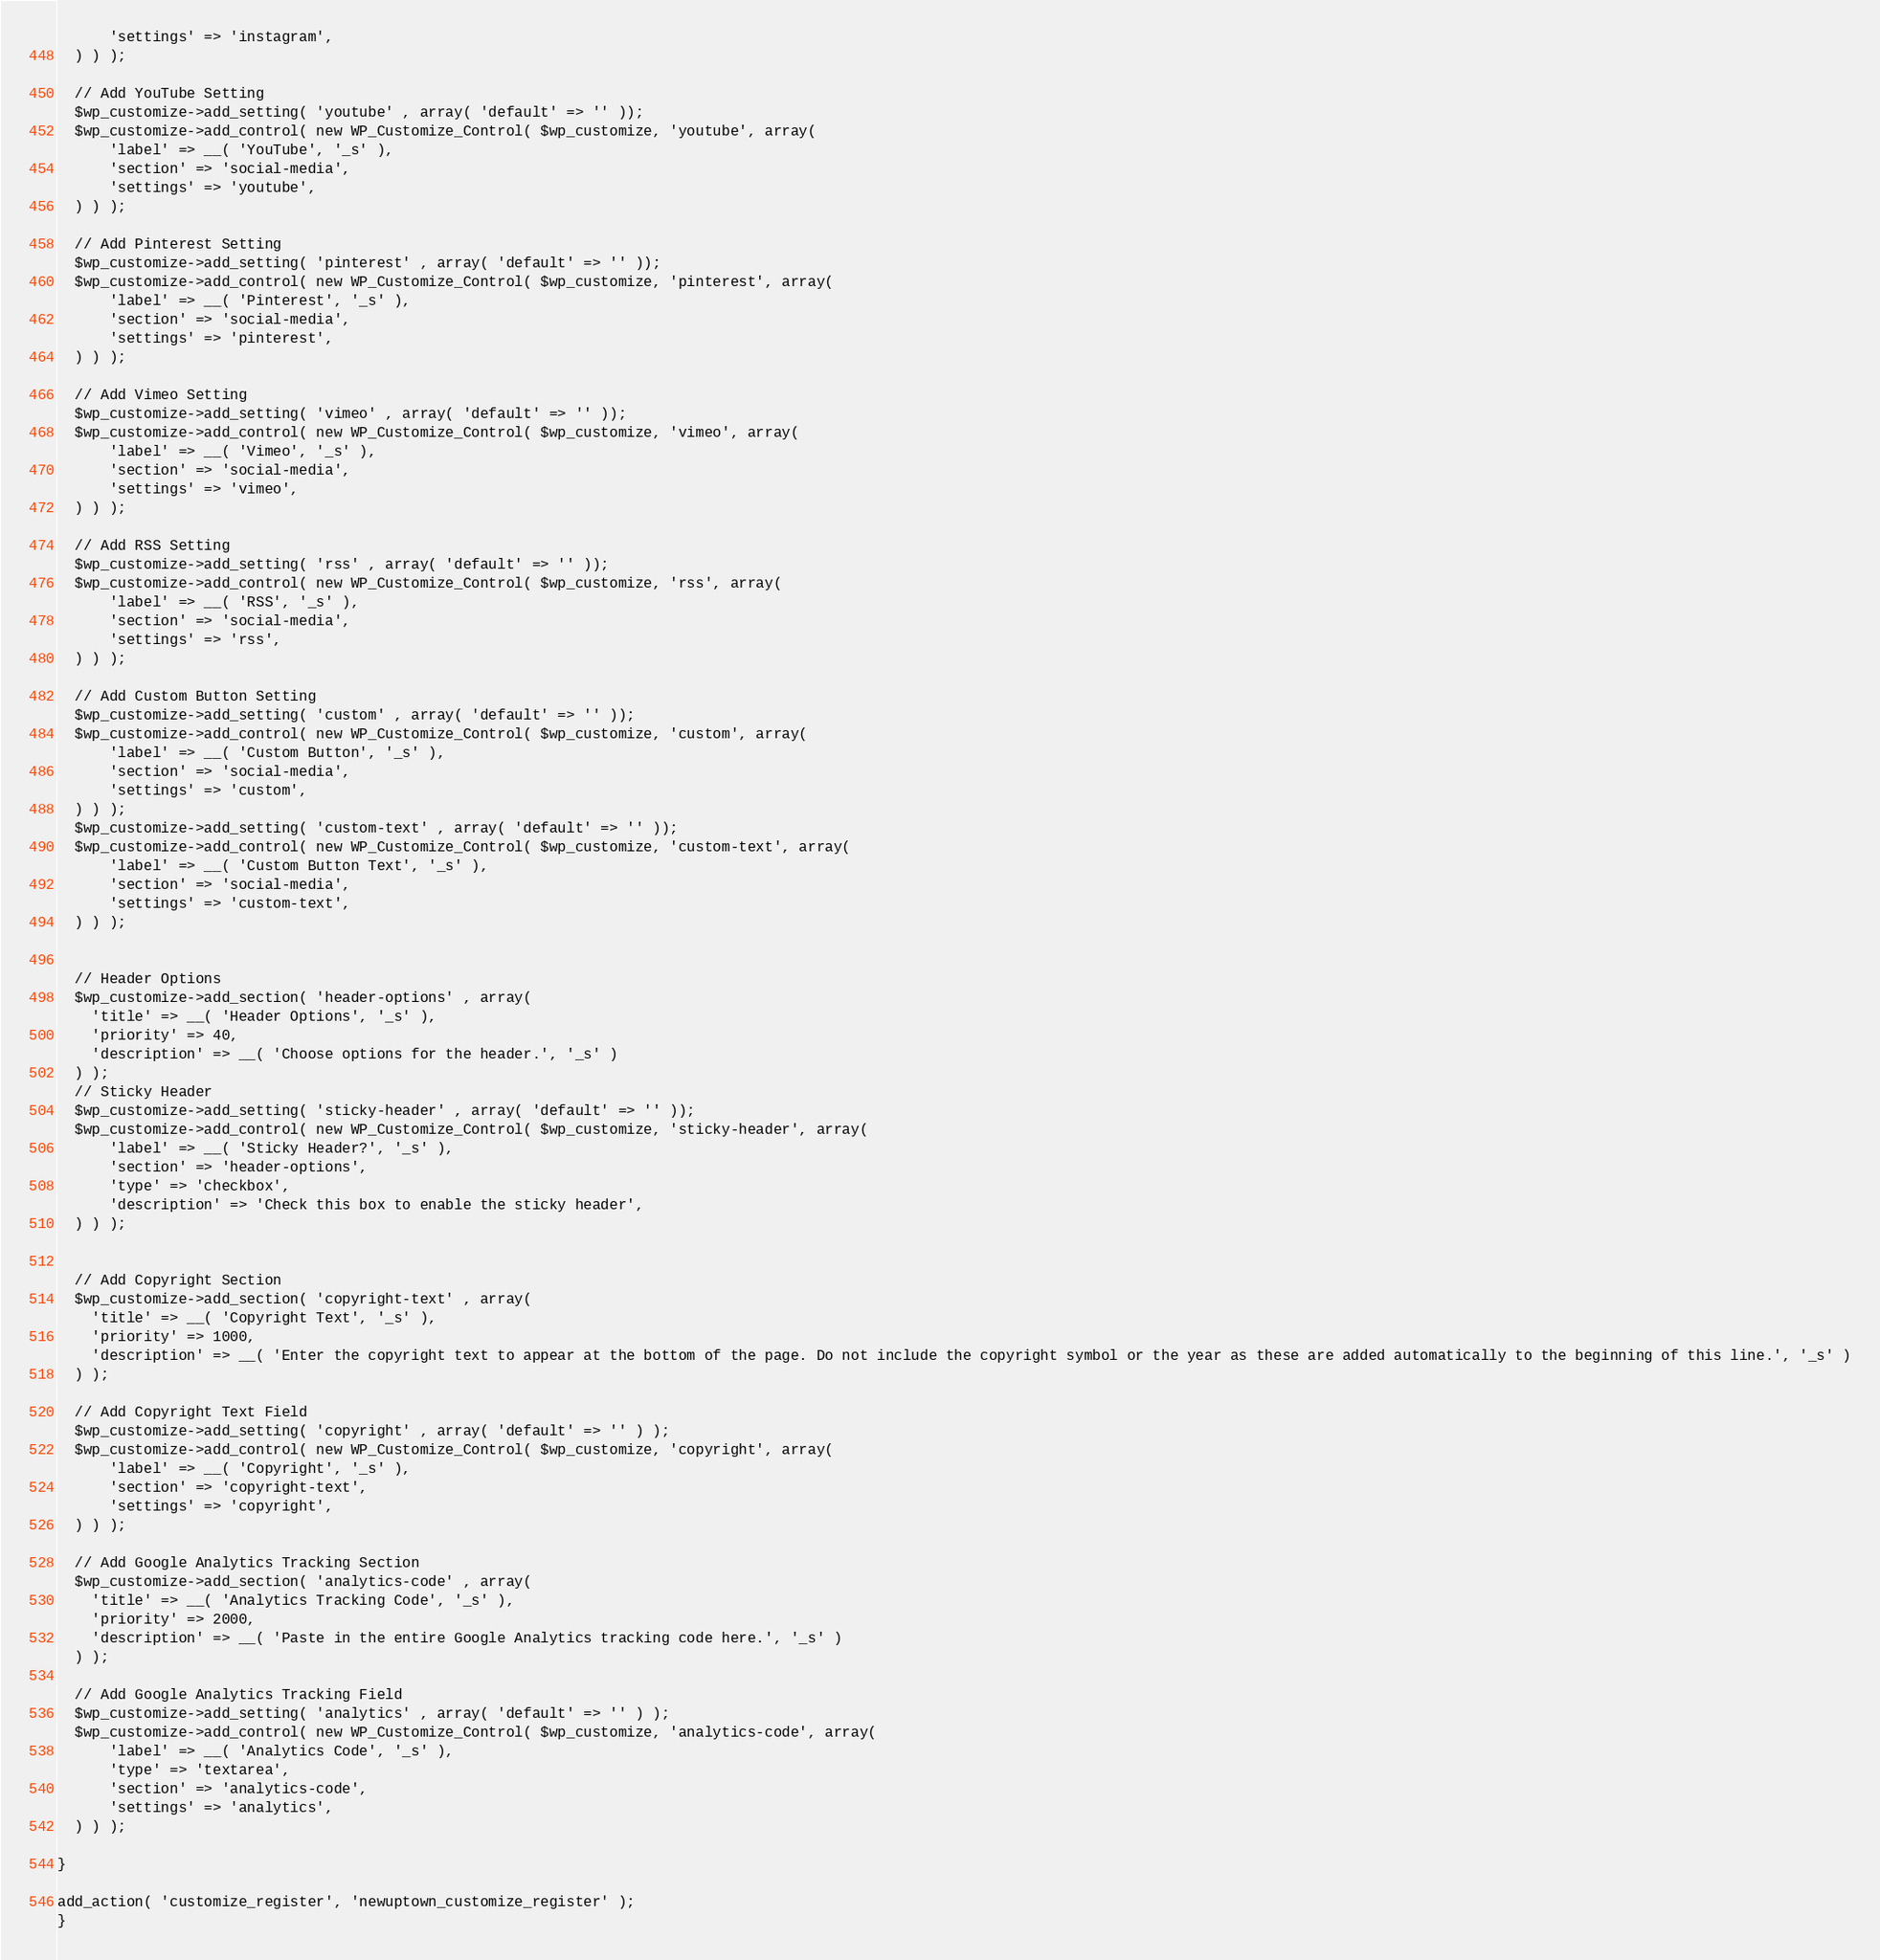Convert code to text. <code><loc_0><loc_0><loc_500><loc_500><_PHP_>      'settings' => 'instagram',
  ) ) );

  // Add YouTube Setting
  $wp_customize->add_setting( 'youtube' , array( 'default' => '' ));
  $wp_customize->add_control( new WP_Customize_Control( $wp_customize, 'youtube', array(
      'label' => __( 'YouTube', '_s' ),
      'section' => 'social-media',
      'settings' => 'youtube',
  ) ) );

  // Add Pinterest Setting
  $wp_customize->add_setting( 'pinterest' , array( 'default' => '' ));
  $wp_customize->add_control( new WP_Customize_Control( $wp_customize, 'pinterest', array(
      'label' => __( 'Pinterest', '_s' ),
      'section' => 'social-media',
      'settings' => 'pinterest',
  ) ) );

  // Add Vimeo Setting
  $wp_customize->add_setting( 'vimeo' , array( 'default' => '' ));
  $wp_customize->add_control( new WP_Customize_Control( $wp_customize, 'vimeo', array(
      'label' => __( 'Vimeo', '_s' ),
      'section' => 'social-media',
      'settings' => 'vimeo',
  ) ) );

  // Add RSS Setting
  $wp_customize->add_setting( 'rss' , array( 'default' => '' ));
  $wp_customize->add_control( new WP_Customize_Control( $wp_customize, 'rss', array(
      'label' => __( 'RSS', '_s' ),
      'section' => 'social-media',
      'settings' => 'rss',
  ) ) );

  // Add Custom Button Setting
  $wp_customize->add_setting( 'custom' , array( 'default' => '' ));
  $wp_customize->add_control( new WP_Customize_Control( $wp_customize, 'custom', array(
      'label' => __( 'Custom Button', '_s' ),
      'section' => 'social-media',
      'settings' => 'custom',
  ) ) );
  $wp_customize->add_setting( 'custom-text' , array( 'default' => '' ));
  $wp_customize->add_control( new WP_Customize_Control( $wp_customize, 'custom-text', array(
      'label' => __( 'Custom Button Text', '_s' ),
      'section' => 'social-media',
      'settings' => 'custom-text',
  ) ) );


  // Header Options
  $wp_customize->add_section( 'header-options' , array(
    'title' => __( 'Header Options', '_s' ),
    'priority' => 40,
    'description' => __( 'Choose options for the header.', '_s' )
  ) );
  // Sticky Header
  $wp_customize->add_setting( 'sticky-header' , array( 'default' => '' ));
  $wp_customize->add_control( new WP_Customize_Control( $wp_customize, 'sticky-header', array(
      'label' => __( 'Sticky Header?', '_s' ),
      'section' => 'header-options',
      'type' => 'checkbox',
      'description' => 'Check this box to enable the sticky header',
  ) ) );


  // Add Copyright Section
  $wp_customize->add_section( 'copyright-text' , array(
    'title' => __( 'Copyright Text', '_s' ),
    'priority' => 1000,
    'description' => __( 'Enter the copyright text to appear at the bottom of the page. Do not include the copyright symbol or the year as these are added automatically to the beginning of this line.', '_s' )
  ) );

  // Add Copyright Text Field
  $wp_customize->add_setting( 'copyright' , array( 'default' => '' ) );
  $wp_customize->add_control( new WP_Customize_Control( $wp_customize, 'copyright', array(
      'label' => __( 'Copyright', '_s' ),
      'section' => 'copyright-text',
      'settings' => 'copyright',
  ) ) );

  // Add Google Analytics Tracking Section
  $wp_customize->add_section( 'analytics-code' , array(
    'title' => __( 'Analytics Tracking Code', '_s' ),
    'priority' => 2000,
    'description' => __( 'Paste in the entire Google Analytics tracking code here.', '_s' )
  ) );

  // Add Google Analytics Tracking Field
  $wp_customize->add_setting( 'analytics' , array( 'default' => '' ) );
  $wp_customize->add_control( new WP_Customize_Control( $wp_customize, 'analytics-code', array(
      'label' => __( 'Analytics Code', '_s' ),
      'type' => 'textarea',
      'section' => 'analytics-code',
      'settings' => 'analytics',
  ) ) );

}

add_action( 'customize_register', 'newuptown_customize_register' );
}
</code> 